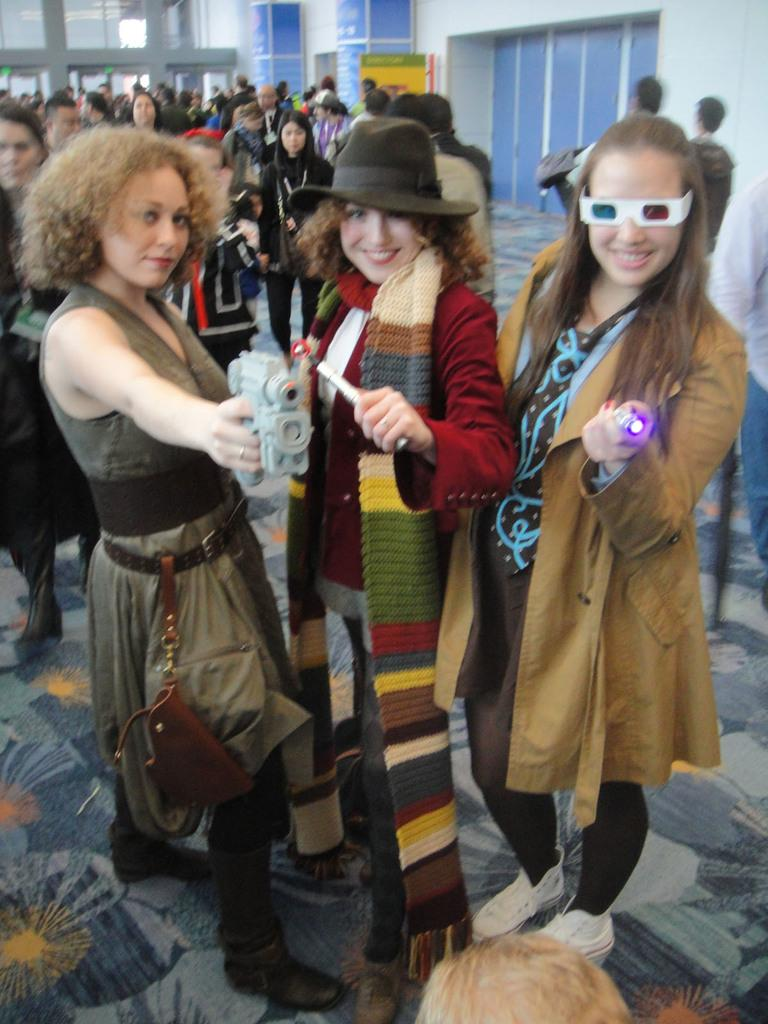How many girls are in the image? There are three girls in the foreground of the image. What are the girls doing in the image? The girls are looking at someone. What can be seen in the background of the image? There are many people standing in the background of the image. What type of arm is visible in the image? There is no arm visible in the image; it only features three girls and many people in the background. 